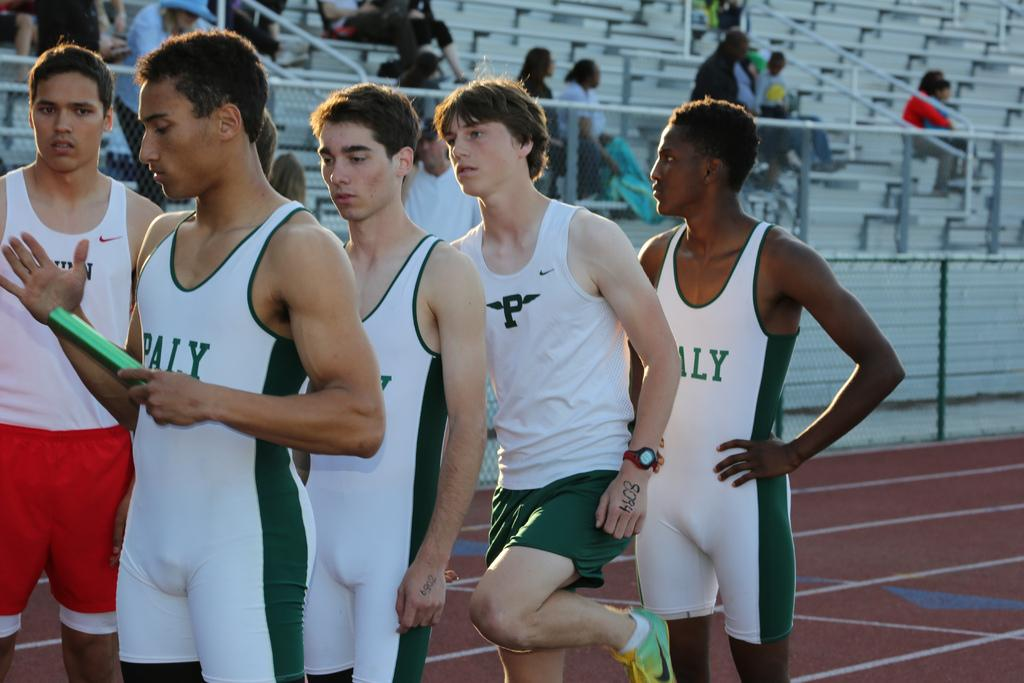<image>
Share a concise interpretation of the image provided. Runners are in line on a track and have the letter p om their uniforms. 